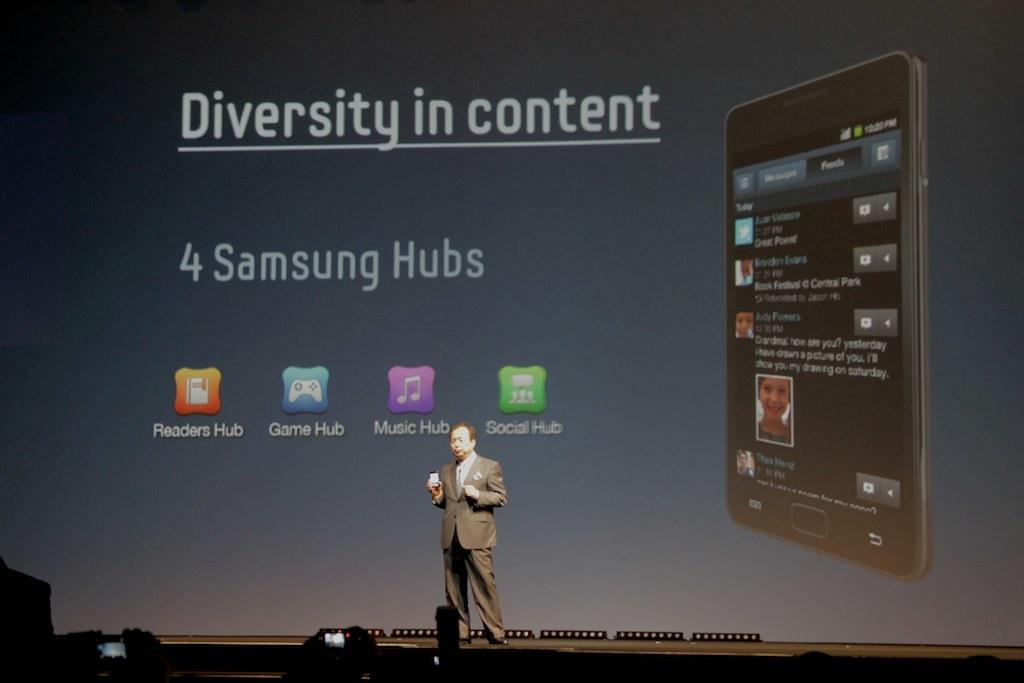<image>
Provide a brief description of the given image. a man standing in front of a huge projection screen that says 'diversity in content' on it 